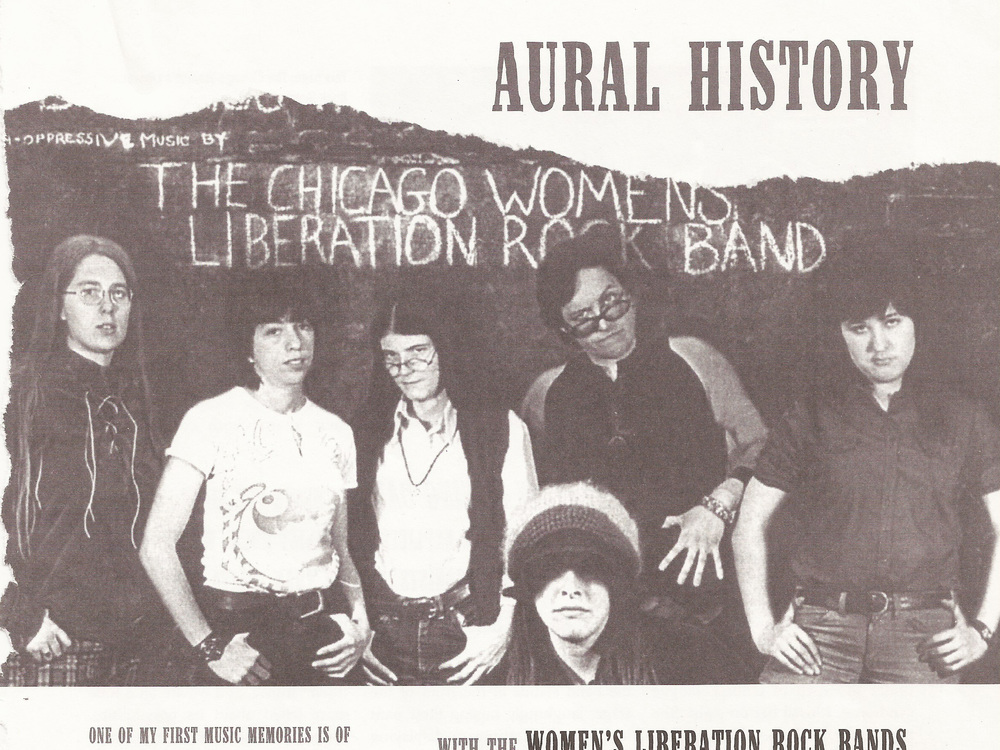What does the overall appearance and expression of the band members suggest about their music style or themes? The collective appearance of the band members, varying from casual to slightly unconventional attire, alongside their earnest and somewhat defiant expressions, projects an air of rebelliousness and authenticity. Such visual cues often reflect a music style that is poignant, lyrically rich, and possibly themed around social and political issues. Their stance and expressions suggest a readiness to challenge the norms, which might be reflected in their music as bold, direct, and resonating with calls for change. 